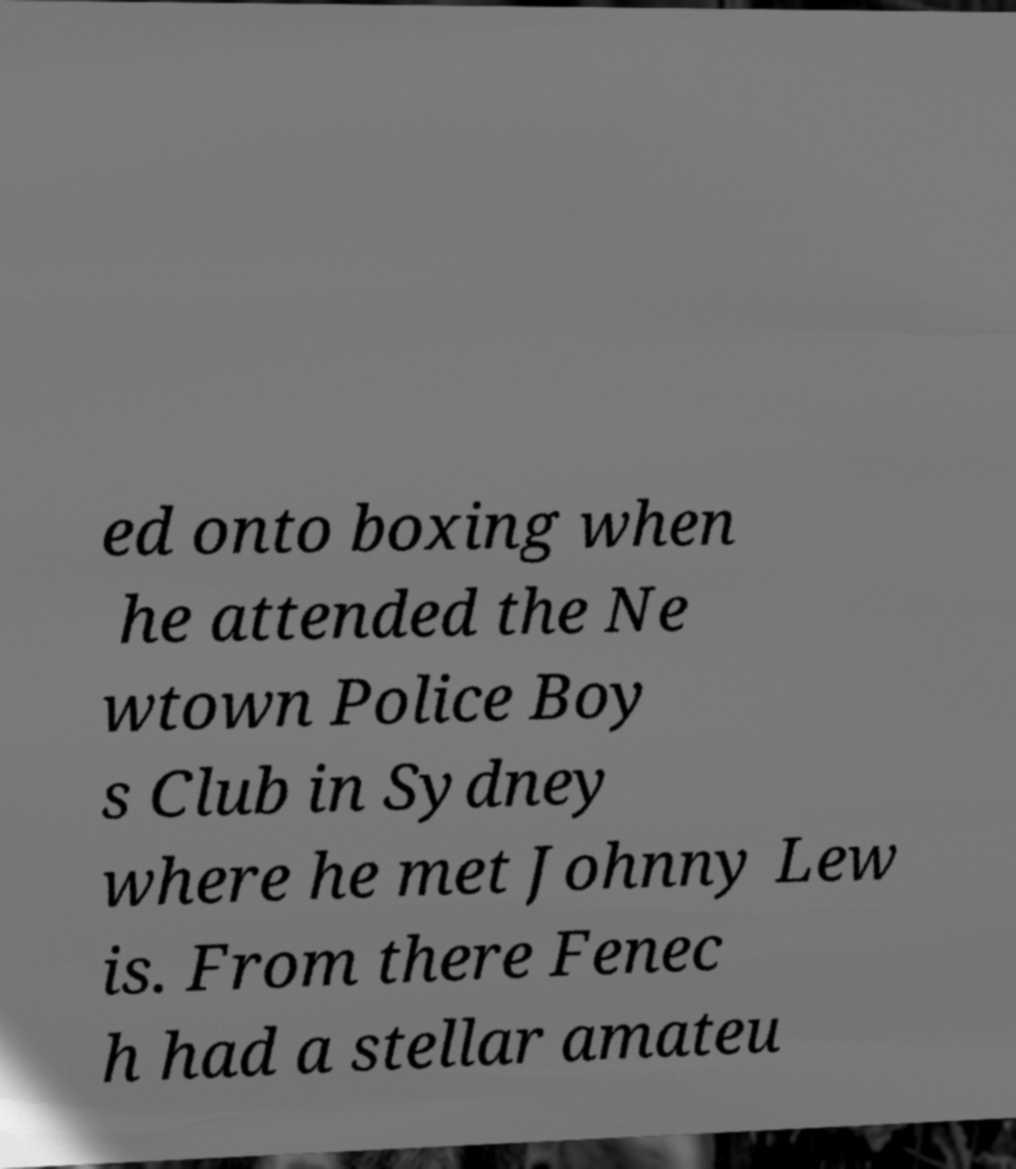Can you read and provide the text displayed in the image?This photo seems to have some interesting text. Can you extract and type it out for me? ed onto boxing when he attended the Ne wtown Police Boy s Club in Sydney where he met Johnny Lew is. From there Fenec h had a stellar amateu 